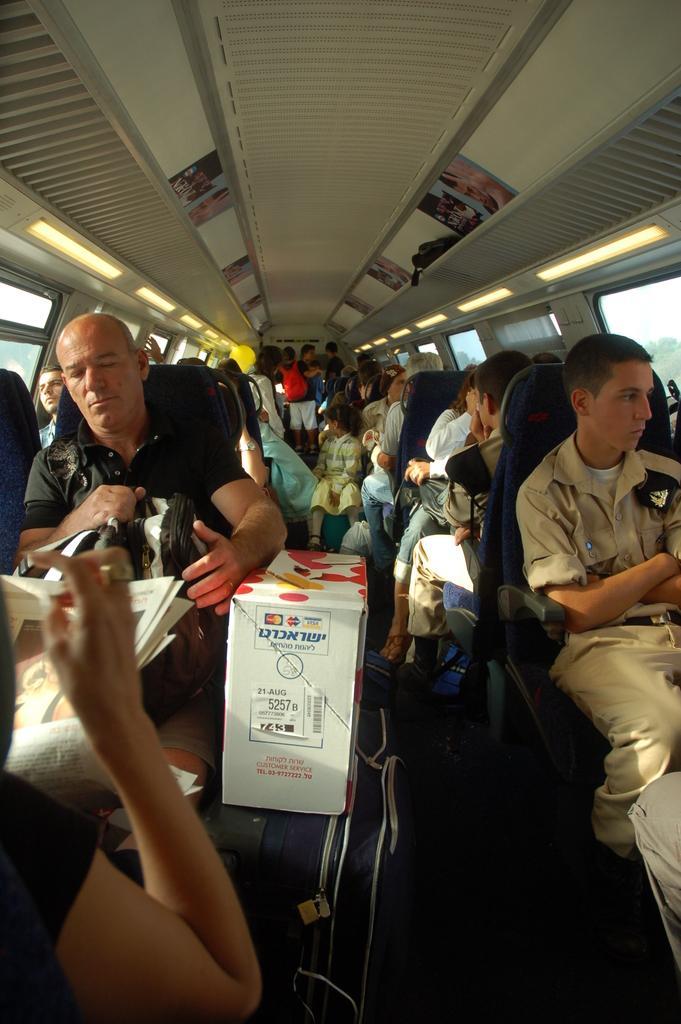Describe this image in one or two sentences. In this picture there are people those who are sitting on chairs in series on the right and left side of the image, it seems to be a bus. 